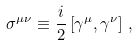<formula> <loc_0><loc_0><loc_500><loc_500>\sigma ^ { \mu \nu } \equiv \frac { i } { 2 } \left [ \gamma ^ { \mu } , \gamma ^ { \nu } \right ] \, ,</formula> 